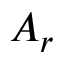<formula> <loc_0><loc_0><loc_500><loc_500>A _ { r }</formula> 